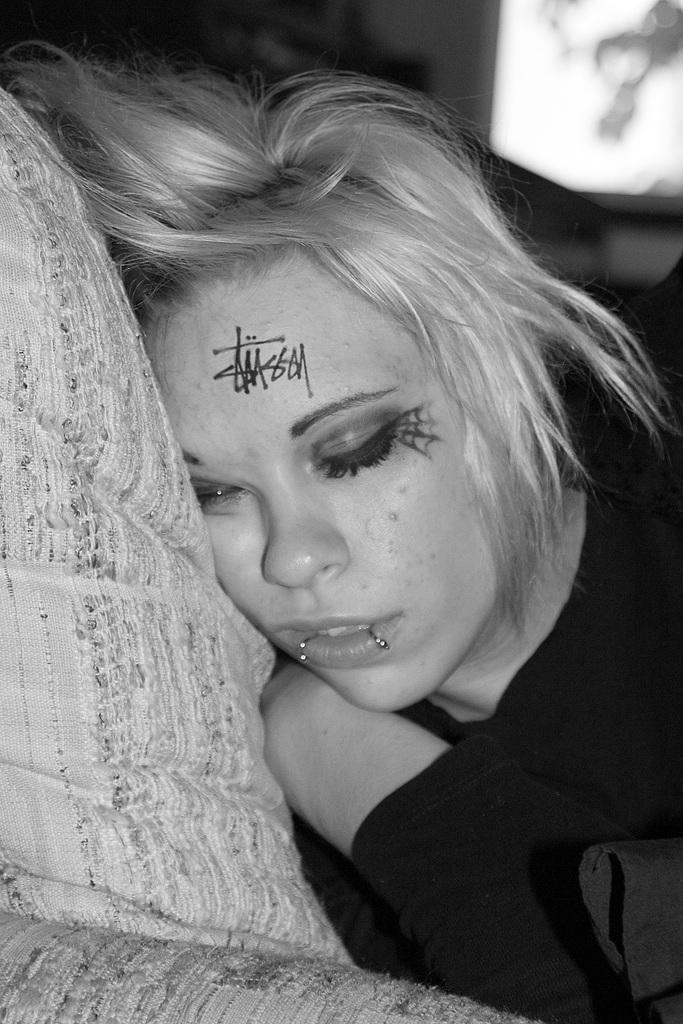Could you give a brief overview of what you see in this image? This picture shows a woman laying on the pillow. She wore a black dress and we see painting on her face. 